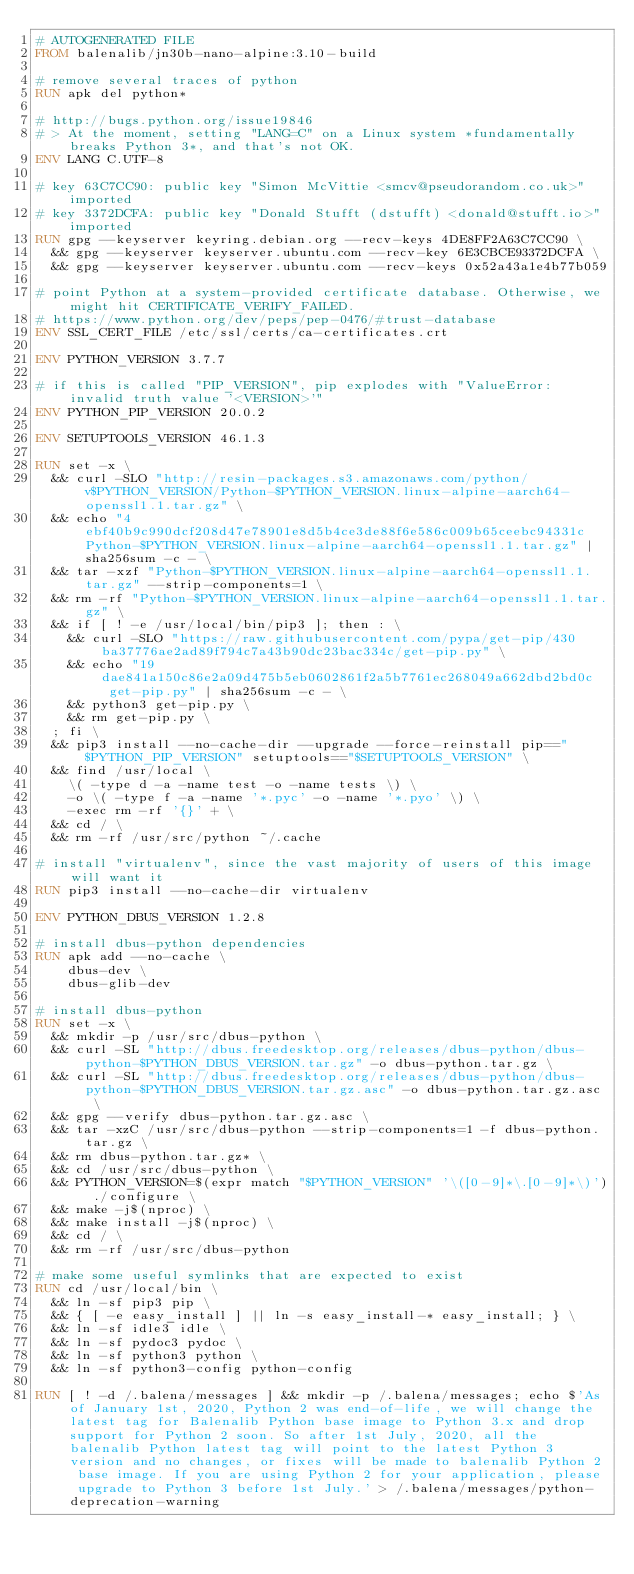Convert code to text. <code><loc_0><loc_0><loc_500><loc_500><_Dockerfile_># AUTOGENERATED FILE
FROM balenalib/jn30b-nano-alpine:3.10-build

# remove several traces of python
RUN apk del python*

# http://bugs.python.org/issue19846
# > At the moment, setting "LANG=C" on a Linux system *fundamentally breaks Python 3*, and that's not OK.
ENV LANG C.UTF-8

# key 63C7CC90: public key "Simon McVittie <smcv@pseudorandom.co.uk>" imported
# key 3372DCFA: public key "Donald Stufft (dstufft) <donald@stufft.io>" imported
RUN gpg --keyserver keyring.debian.org --recv-keys 4DE8FF2A63C7CC90 \
	&& gpg --keyserver keyserver.ubuntu.com --recv-key 6E3CBCE93372DCFA \
	&& gpg --keyserver keyserver.ubuntu.com --recv-keys 0x52a43a1e4b77b059

# point Python at a system-provided certificate database. Otherwise, we might hit CERTIFICATE_VERIFY_FAILED.
# https://www.python.org/dev/peps/pep-0476/#trust-database
ENV SSL_CERT_FILE /etc/ssl/certs/ca-certificates.crt

ENV PYTHON_VERSION 3.7.7

# if this is called "PIP_VERSION", pip explodes with "ValueError: invalid truth value '<VERSION>'"
ENV PYTHON_PIP_VERSION 20.0.2

ENV SETUPTOOLS_VERSION 46.1.3

RUN set -x \
	&& curl -SLO "http://resin-packages.s3.amazonaws.com/python/v$PYTHON_VERSION/Python-$PYTHON_VERSION.linux-alpine-aarch64-openssl1.1.tar.gz" \
	&& echo "4ebf40b9c990dcf208d47e78901e8d5b4ce3de88f6e586c009b65ceebc94331c  Python-$PYTHON_VERSION.linux-alpine-aarch64-openssl1.1.tar.gz" | sha256sum -c - \
	&& tar -xzf "Python-$PYTHON_VERSION.linux-alpine-aarch64-openssl1.1.tar.gz" --strip-components=1 \
	&& rm -rf "Python-$PYTHON_VERSION.linux-alpine-aarch64-openssl1.1.tar.gz" \
	&& if [ ! -e /usr/local/bin/pip3 ]; then : \
		&& curl -SLO "https://raw.githubusercontent.com/pypa/get-pip/430ba37776ae2ad89f794c7a43b90dc23bac334c/get-pip.py" \
		&& echo "19dae841a150c86e2a09d475b5eb0602861f2a5b7761ec268049a662dbd2bd0c  get-pip.py" | sha256sum -c - \
		&& python3 get-pip.py \
		&& rm get-pip.py \
	; fi \
	&& pip3 install --no-cache-dir --upgrade --force-reinstall pip=="$PYTHON_PIP_VERSION" setuptools=="$SETUPTOOLS_VERSION" \
	&& find /usr/local \
		\( -type d -a -name test -o -name tests \) \
		-o \( -type f -a -name '*.pyc' -o -name '*.pyo' \) \
		-exec rm -rf '{}' + \
	&& cd / \
	&& rm -rf /usr/src/python ~/.cache

# install "virtualenv", since the vast majority of users of this image will want it
RUN pip3 install --no-cache-dir virtualenv

ENV PYTHON_DBUS_VERSION 1.2.8

# install dbus-python dependencies 
RUN apk add --no-cache \
		dbus-dev \
		dbus-glib-dev

# install dbus-python
RUN set -x \
	&& mkdir -p /usr/src/dbus-python \
	&& curl -SL "http://dbus.freedesktop.org/releases/dbus-python/dbus-python-$PYTHON_DBUS_VERSION.tar.gz" -o dbus-python.tar.gz \
	&& curl -SL "http://dbus.freedesktop.org/releases/dbus-python/dbus-python-$PYTHON_DBUS_VERSION.tar.gz.asc" -o dbus-python.tar.gz.asc \
	&& gpg --verify dbus-python.tar.gz.asc \
	&& tar -xzC /usr/src/dbus-python --strip-components=1 -f dbus-python.tar.gz \
	&& rm dbus-python.tar.gz* \
	&& cd /usr/src/dbus-python \
	&& PYTHON_VERSION=$(expr match "$PYTHON_VERSION" '\([0-9]*\.[0-9]*\)') ./configure \
	&& make -j$(nproc) \
	&& make install -j$(nproc) \
	&& cd / \
	&& rm -rf /usr/src/dbus-python

# make some useful symlinks that are expected to exist
RUN cd /usr/local/bin \
	&& ln -sf pip3 pip \
	&& { [ -e easy_install ] || ln -s easy_install-* easy_install; } \
	&& ln -sf idle3 idle \
	&& ln -sf pydoc3 pydoc \
	&& ln -sf python3 python \
	&& ln -sf python3-config python-config

RUN [ ! -d /.balena/messages ] && mkdir -p /.balena/messages; echo $'As of January 1st, 2020, Python 2 was end-of-life, we will change the latest tag for Balenalib Python base image to Python 3.x and drop support for Python 2 soon. So after 1st July, 2020, all the balenalib Python latest tag will point to the latest Python 3 version and no changes, or fixes will be made to balenalib Python 2 base image. If you are using Python 2 for your application, please upgrade to Python 3 before 1st July.' > /.balena/messages/python-deprecation-warning
</code> 